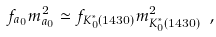Convert formula to latex. <formula><loc_0><loc_0><loc_500><loc_500>f _ { a _ { 0 } } m _ { a _ { 0 } } ^ { 2 } \simeq f _ { K _ { 0 } ^ { * } ( 1 4 3 0 ) } m _ { K _ { 0 } ^ { * } ( 1 4 3 0 ) } ^ { 2 } \ ,</formula> 